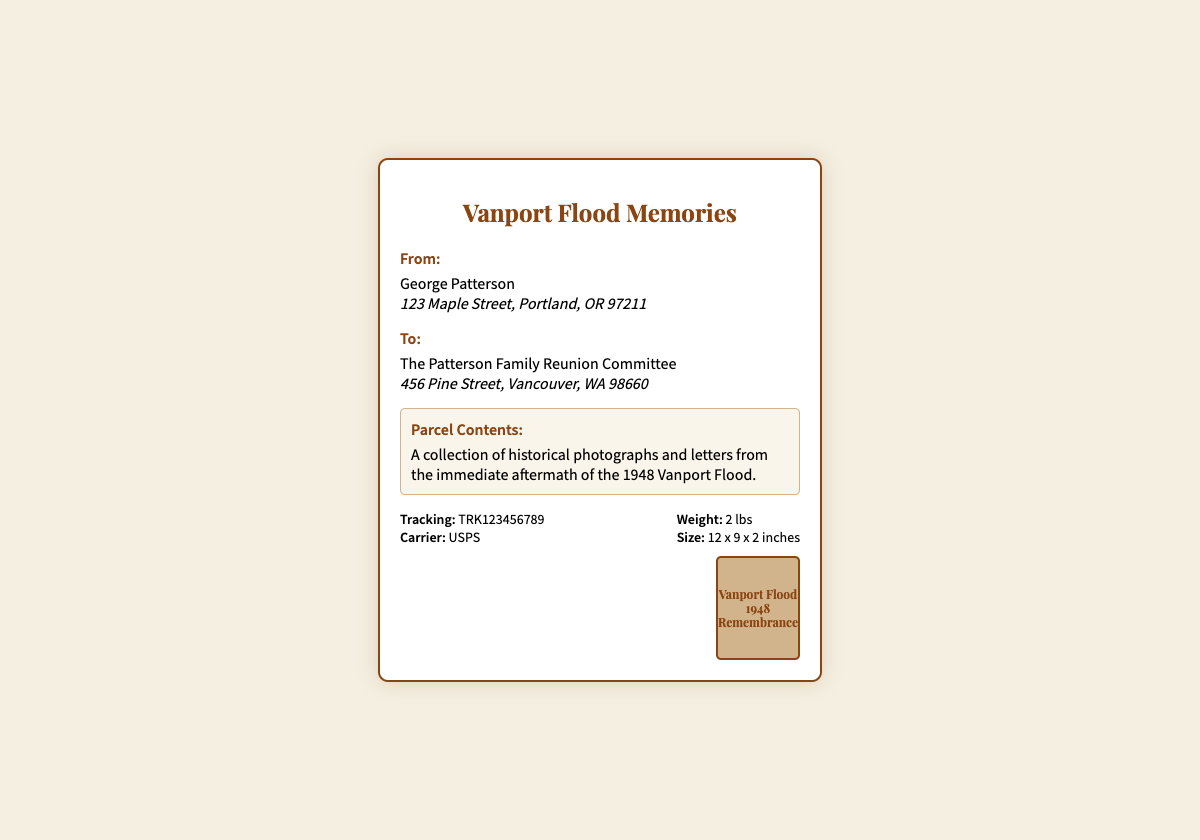What is the name of the sender? The sender's name is specifically mentioned at the top of the label under the 'From:' section.
Answer: George Patterson What is the address of the sender? The sender's address is provided beneath their name, detailing the location of George Patterson.
Answer: 123 Maple Street, Portland, OR 97211 What is the name of the recipient? The recipient's name is listed under the 'To:' section of the document.
Answer: The Patterson Family Reunion Committee What is the address of the recipient? The recipient's address is found beneath their name in the 'To:' section.
Answer: 456 Pine Street, Vancouver, WA 98660 What are the contents of the parcel? The contents of the parcel are described in the 'Parcel Contents' section of the document.
Answer: A collection of historical photographs and letters from the immediate aftermath of the 1948 Vanport Flood What is the tracking number? The tracking number is displayed in the 'shipping details' part of the label.
Answer: TRK123456789 What is the weight of the parcel? The weight is indicated in the 'shipping details' section clearly stating the weight of the parcel.
Answer: 2 lbs What carrier is used for the shipment? The carrier's name is mentioned in the 'shipping details' section of the document.
Answer: USPS What is the size of the parcel? The size dimensions are specified in the 'shipping details' section, providing clear measurements.
Answer: 12 x 9 x 2 inches What does the vintage stamp refer to? The vintage stamp mentions a specific event commemorating the important historical event from 1948, clearly noted at the bottom.
Answer: Vanport Flood 1948 Remembrance 